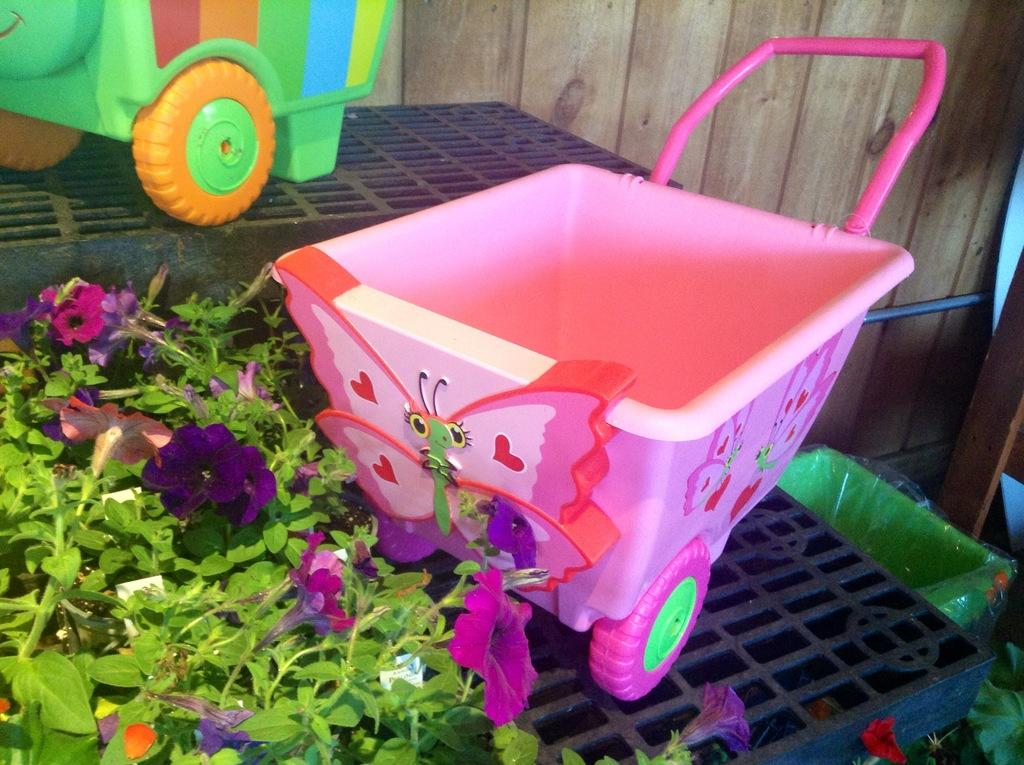What items can be seen on the table in the image? There are toys, flowers, and plants on the table in the image. What else is visible near the table? There are objects beside the table. What can be seen in the background of the image? There is a wooden wall in the background. How many lizards are crawling on the wooden wall in the image? There are no lizards present in the image; only the wooden wall can be seen in the background. 